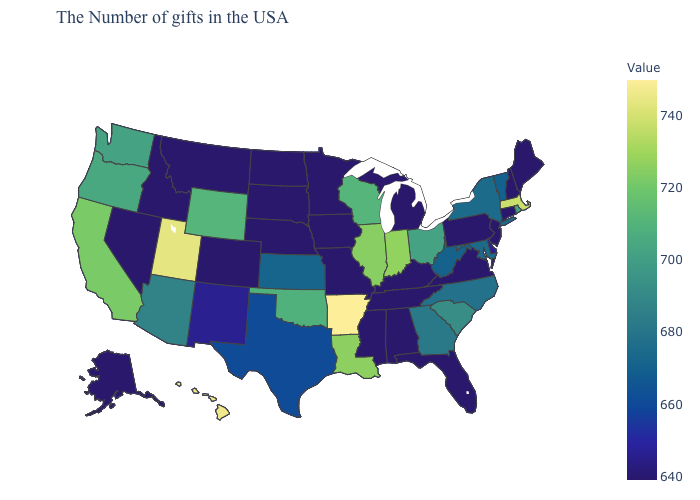Does Arkansas have the highest value in the USA?
Give a very brief answer. Yes. Does Iowa have the lowest value in the MidWest?
Short answer required. Yes. Among the states that border Missouri , which have the highest value?
Give a very brief answer. Arkansas. Does Massachusetts have a higher value than Arkansas?
Keep it brief. No. Does the map have missing data?
Quick response, please. No. Which states have the lowest value in the USA?
Answer briefly. Maine, New Hampshire, Connecticut, New Jersey, Pennsylvania, Virginia, Florida, Michigan, Kentucky, Alabama, Tennessee, Mississippi, Missouri, Minnesota, Iowa, Nebraska, South Dakota, North Dakota, Colorado, Montana, Idaho, Nevada, Alaska. 